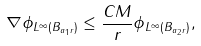Convert formula to latex. <formula><loc_0><loc_0><loc_500><loc_500>\| \nabla \phi \| _ { L ^ { \infty } ( B _ { a _ { 1 } r } ) } \leq \frac { C M } { r } \| \phi \| _ { L ^ { \infty } ( B _ { a _ { 2 } r } ) } ,</formula> 